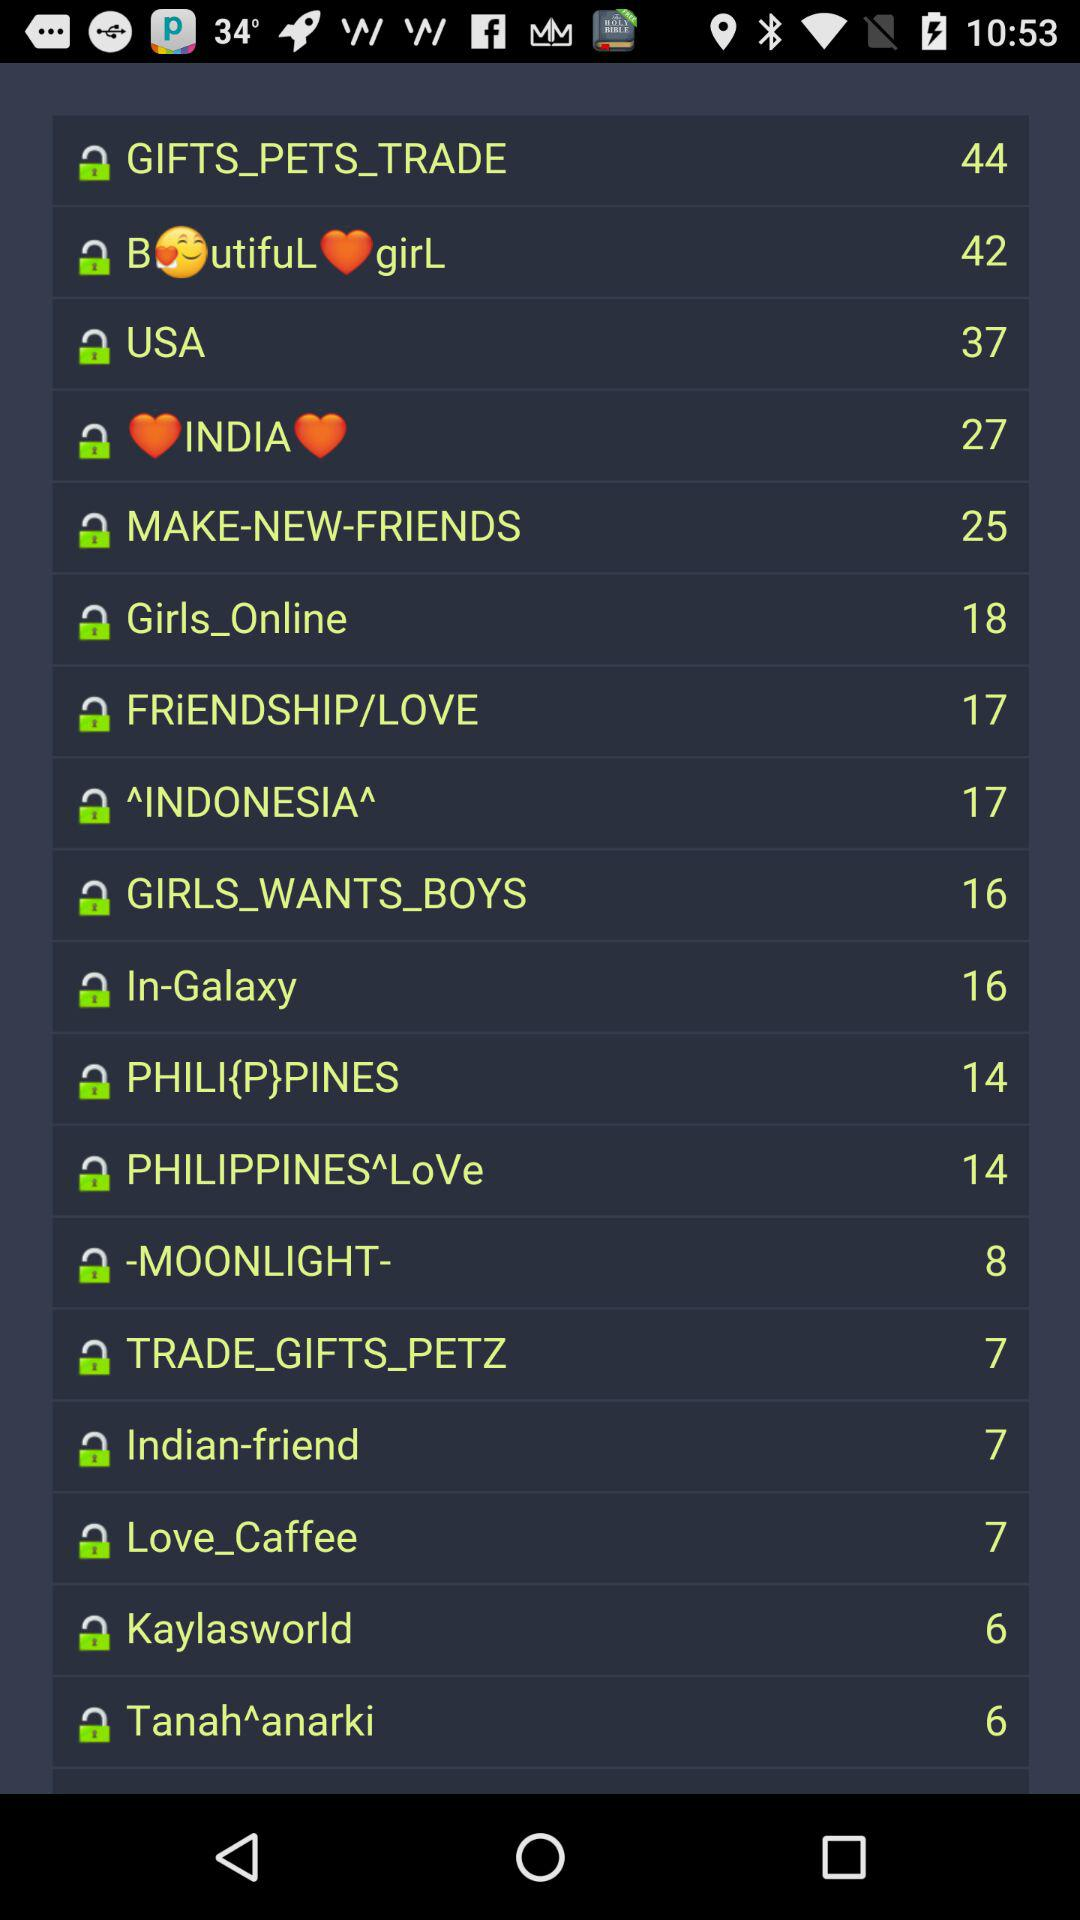What is the number of "Girls_Online"? The number is 18. 